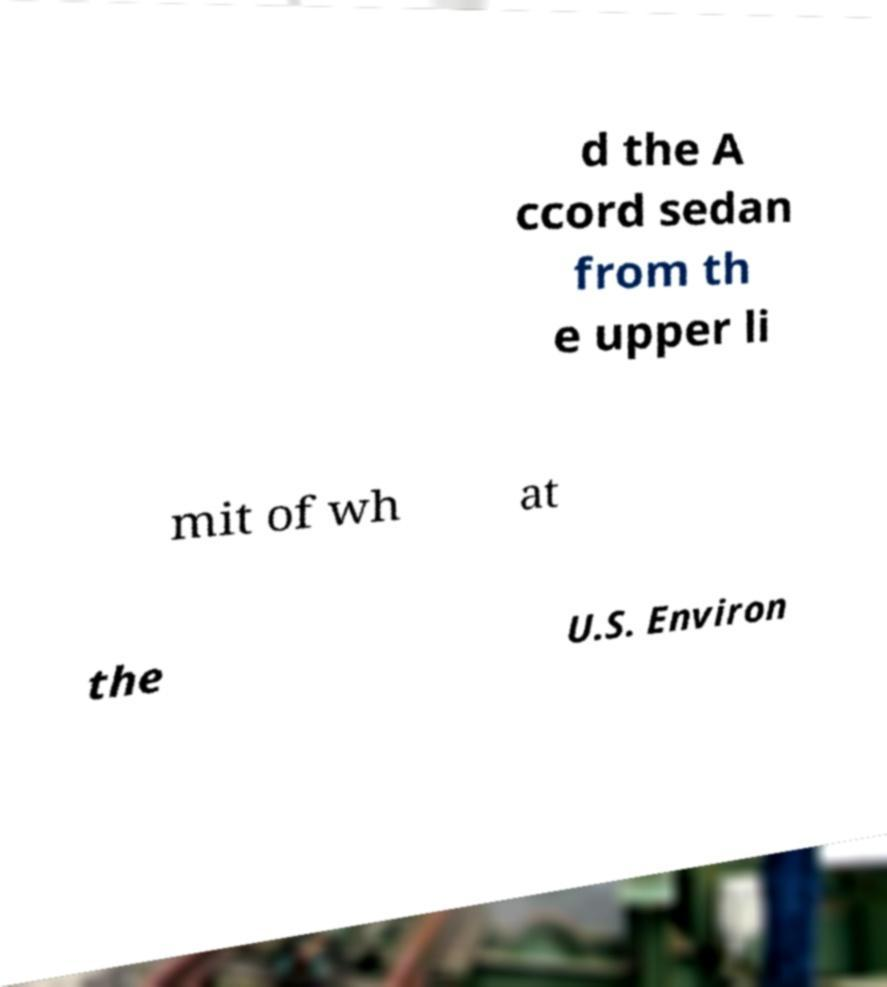Can you read and provide the text displayed in the image?This photo seems to have some interesting text. Can you extract and type it out for me? d the A ccord sedan from th e upper li mit of wh at the U.S. Environ 